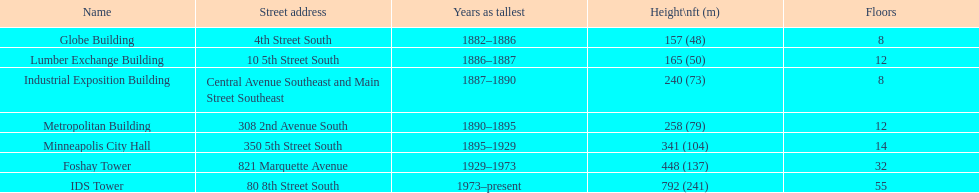Which building is taller - the metropolitan building or the lumber exchange building? Metropolitan Building. 